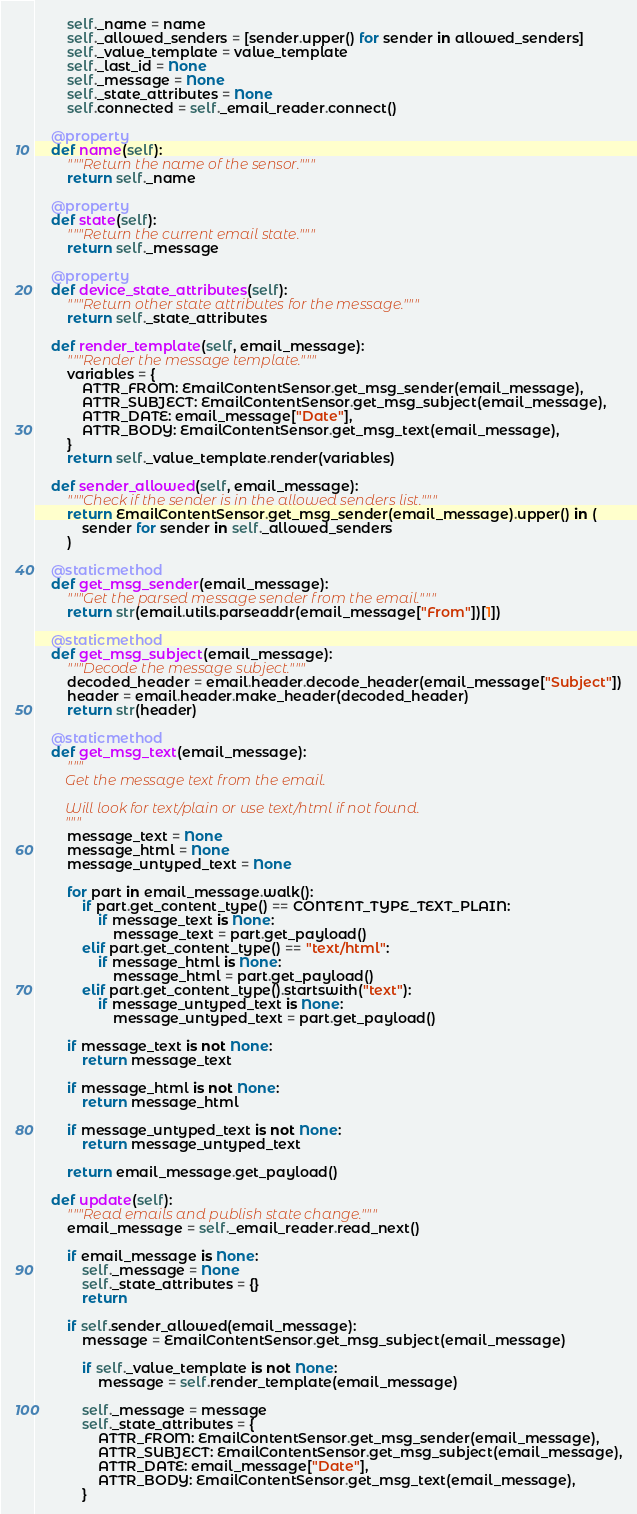<code> <loc_0><loc_0><loc_500><loc_500><_Python_>        self._name = name
        self._allowed_senders = [sender.upper() for sender in allowed_senders]
        self._value_template = value_template
        self._last_id = None
        self._message = None
        self._state_attributes = None
        self.connected = self._email_reader.connect()

    @property
    def name(self):
        """Return the name of the sensor."""
        return self._name

    @property
    def state(self):
        """Return the current email state."""
        return self._message

    @property
    def device_state_attributes(self):
        """Return other state attributes for the message."""
        return self._state_attributes

    def render_template(self, email_message):
        """Render the message template."""
        variables = {
            ATTR_FROM: EmailContentSensor.get_msg_sender(email_message),
            ATTR_SUBJECT: EmailContentSensor.get_msg_subject(email_message),
            ATTR_DATE: email_message["Date"],
            ATTR_BODY: EmailContentSensor.get_msg_text(email_message),
        }
        return self._value_template.render(variables)

    def sender_allowed(self, email_message):
        """Check if the sender is in the allowed senders list."""
        return EmailContentSensor.get_msg_sender(email_message).upper() in (
            sender for sender in self._allowed_senders
        )

    @staticmethod
    def get_msg_sender(email_message):
        """Get the parsed message sender from the email."""
        return str(email.utils.parseaddr(email_message["From"])[1])

    @staticmethod
    def get_msg_subject(email_message):
        """Decode the message subject."""
        decoded_header = email.header.decode_header(email_message["Subject"])
        header = email.header.make_header(decoded_header)
        return str(header)

    @staticmethod
    def get_msg_text(email_message):
        """
        Get the message text from the email.

        Will look for text/plain or use text/html if not found.
        """
        message_text = None
        message_html = None
        message_untyped_text = None

        for part in email_message.walk():
            if part.get_content_type() == CONTENT_TYPE_TEXT_PLAIN:
                if message_text is None:
                    message_text = part.get_payload()
            elif part.get_content_type() == "text/html":
                if message_html is None:
                    message_html = part.get_payload()
            elif part.get_content_type().startswith("text"):
                if message_untyped_text is None:
                    message_untyped_text = part.get_payload()

        if message_text is not None:
            return message_text

        if message_html is not None:
            return message_html

        if message_untyped_text is not None:
            return message_untyped_text

        return email_message.get_payload()

    def update(self):
        """Read emails and publish state change."""
        email_message = self._email_reader.read_next()

        if email_message is None:
            self._message = None
            self._state_attributes = {}
            return

        if self.sender_allowed(email_message):
            message = EmailContentSensor.get_msg_subject(email_message)

            if self._value_template is not None:
                message = self.render_template(email_message)

            self._message = message
            self._state_attributes = {
                ATTR_FROM: EmailContentSensor.get_msg_sender(email_message),
                ATTR_SUBJECT: EmailContentSensor.get_msg_subject(email_message),
                ATTR_DATE: email_message["Date"],
                ATTR_BODY: EmailContentSensor.get_msg_text(email_message),
            }
</code> 